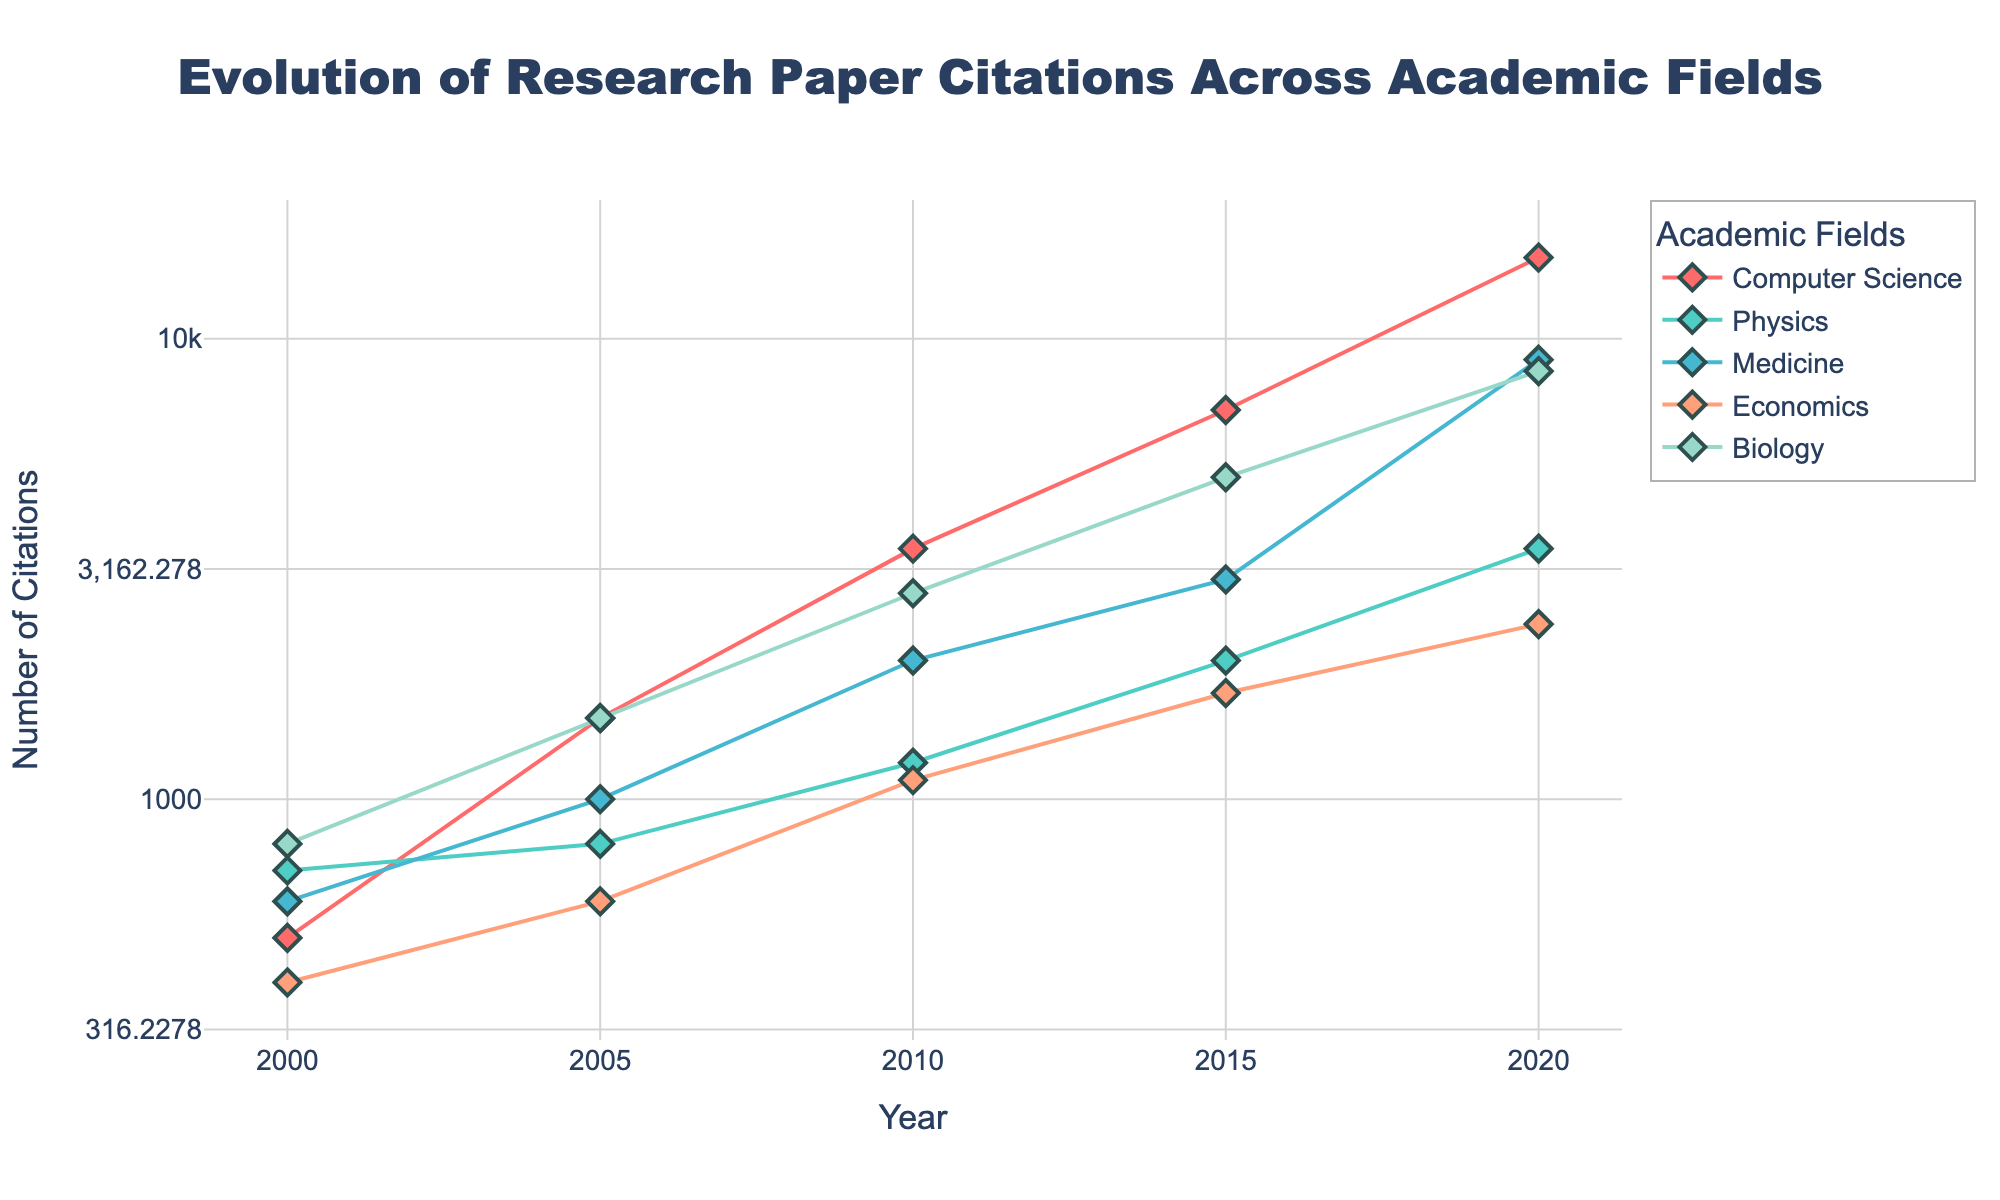What is the title of the plot? The title is shown at the top of the plot and usually summarizes the overall content of the figure.
Answer: Evolution of Research Paper Citations Across Academic Fields What are the academic fields represented in the plot? Various academic fields are represented through different colored lines and are also listed in the legend on the right side of the plot.
Answer: Computer Science, Physics, Medicine, Economics, Biology Which field had the highest number of citations in 2020? To find the field with the highest number of citations in 2020, we look at the point on the plot for each field in the year 2020 and compare their values.
Answer: Computer Science How many times did Physics citations increase from 2000 to 2020? The number of citations for Physics in 2000 is 700 and in 2020 is 3500. Calculate the increase by (3500 / 700).
Answer: 5 times Which field had the smallest increase in citations from 2015 to 2020? We need to look at the citations for each field in 2015 and 2020, compute the difference, and identify the one with the smallest increase.
Answer: Physics During which period did Medicine see the largest growth in citations? Observing the Medicine line, the largest growth appears where the slope of the line is steepest. Compare the increments between each pair of consecutive years.
Answer: 2015 to 2020 What is the overall trend in the number of citations for Economics from 2000 to 2020? Check the markers for Economics from 2000 to 2020. The line indicates steady upward movement.
Answer: Increasing trend Compare the citation numbers of Biology and Medicine in 2015. Which had more citations and by how much? Look at the points for Biology and Medicine in 2015; Biology has 5000 and Medicine has 3000 citations. Subtract Medicine's citations from Biology's.
Answer: Biology, 2000 more What is the log-scaled y-axis range used in this plot? The y-axis is log-scaled and its range is visible from the axis markers and the plot settings. It transforms y-values into a logarithmic scale from 300 to 20000.
Answer: 300 to 20000 Identify any field that shows a consistent upward trend across all years. Look at the trend lines for each field from 2000 to 2020 and identify which field's number of citations steadily increases without noticeable drops.
Answer: Biology 